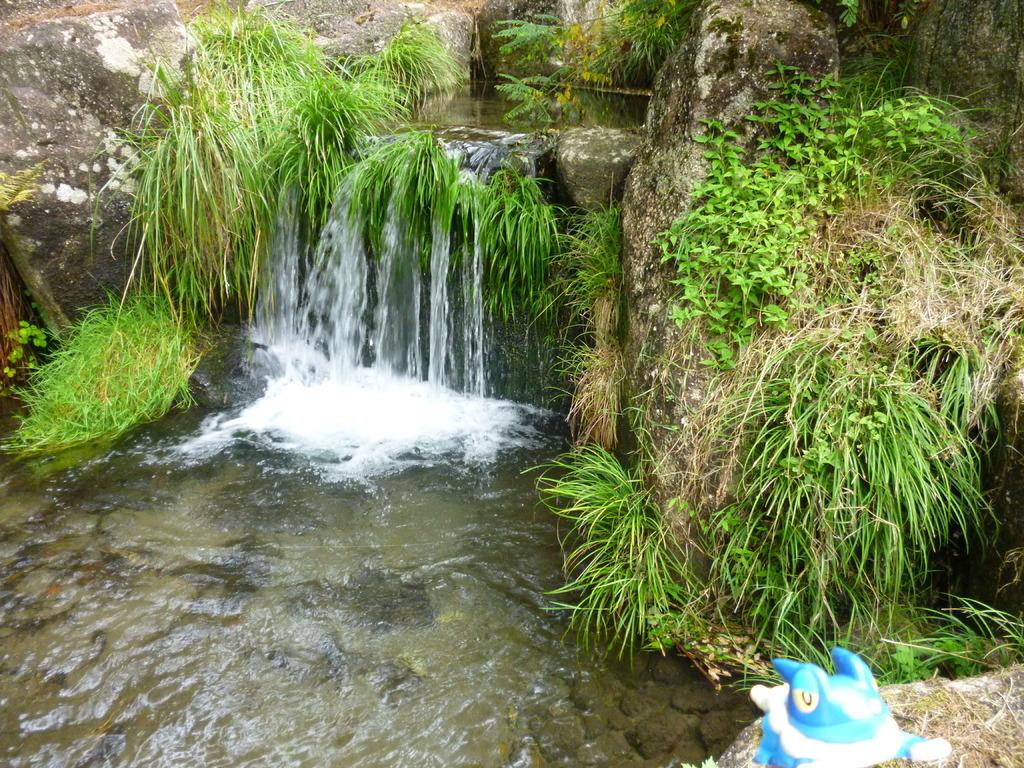What object can be found in the bottom right side of the image? There is a toy in the bottom right side of the image. What colors are used for the toy? The toy is blue and white in color. What type of natural environment is visible in the background of the image? There is grass, stones, and water visible in the background of the image. What direction does the zephyr blow in the image? There is no mention of a zephyr in the image, so it cannot be determined which direction it would blow. 